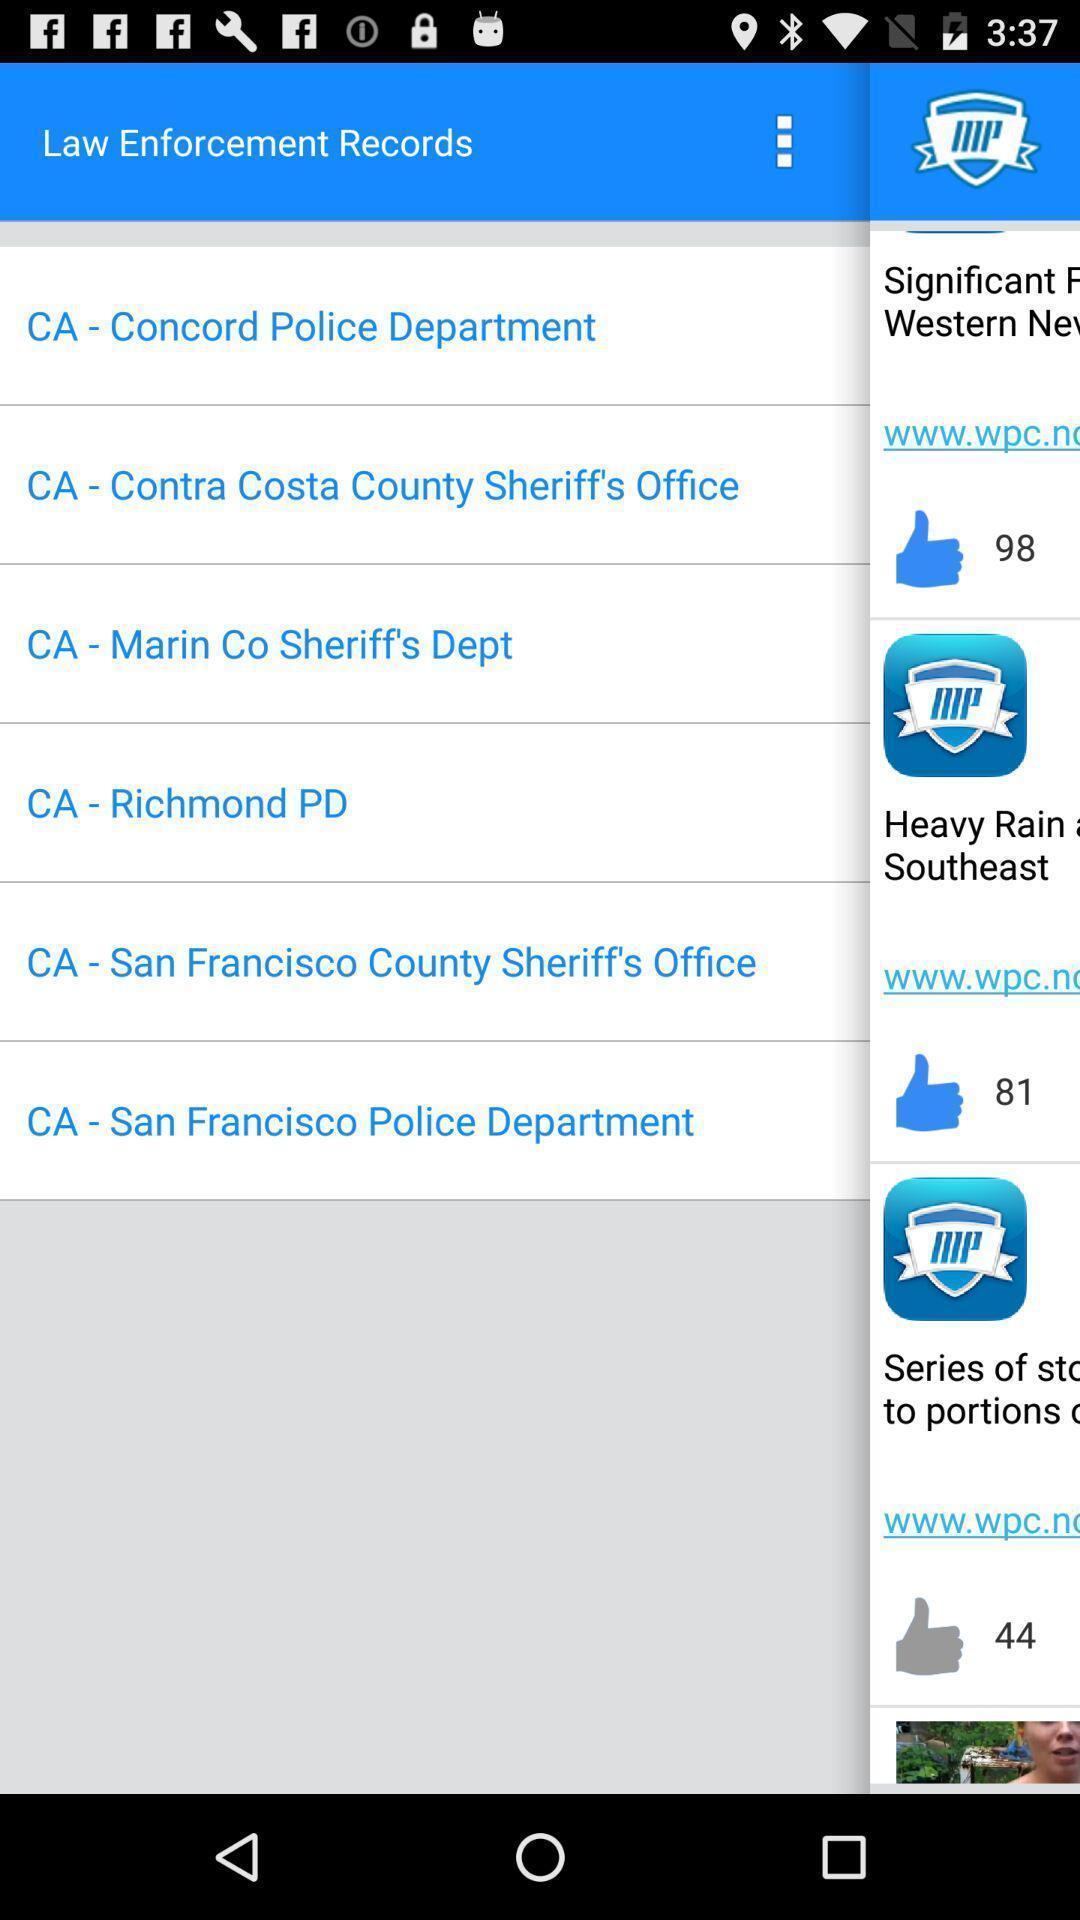Explain the elements present in this screenshot. Page showing a variety of records. 